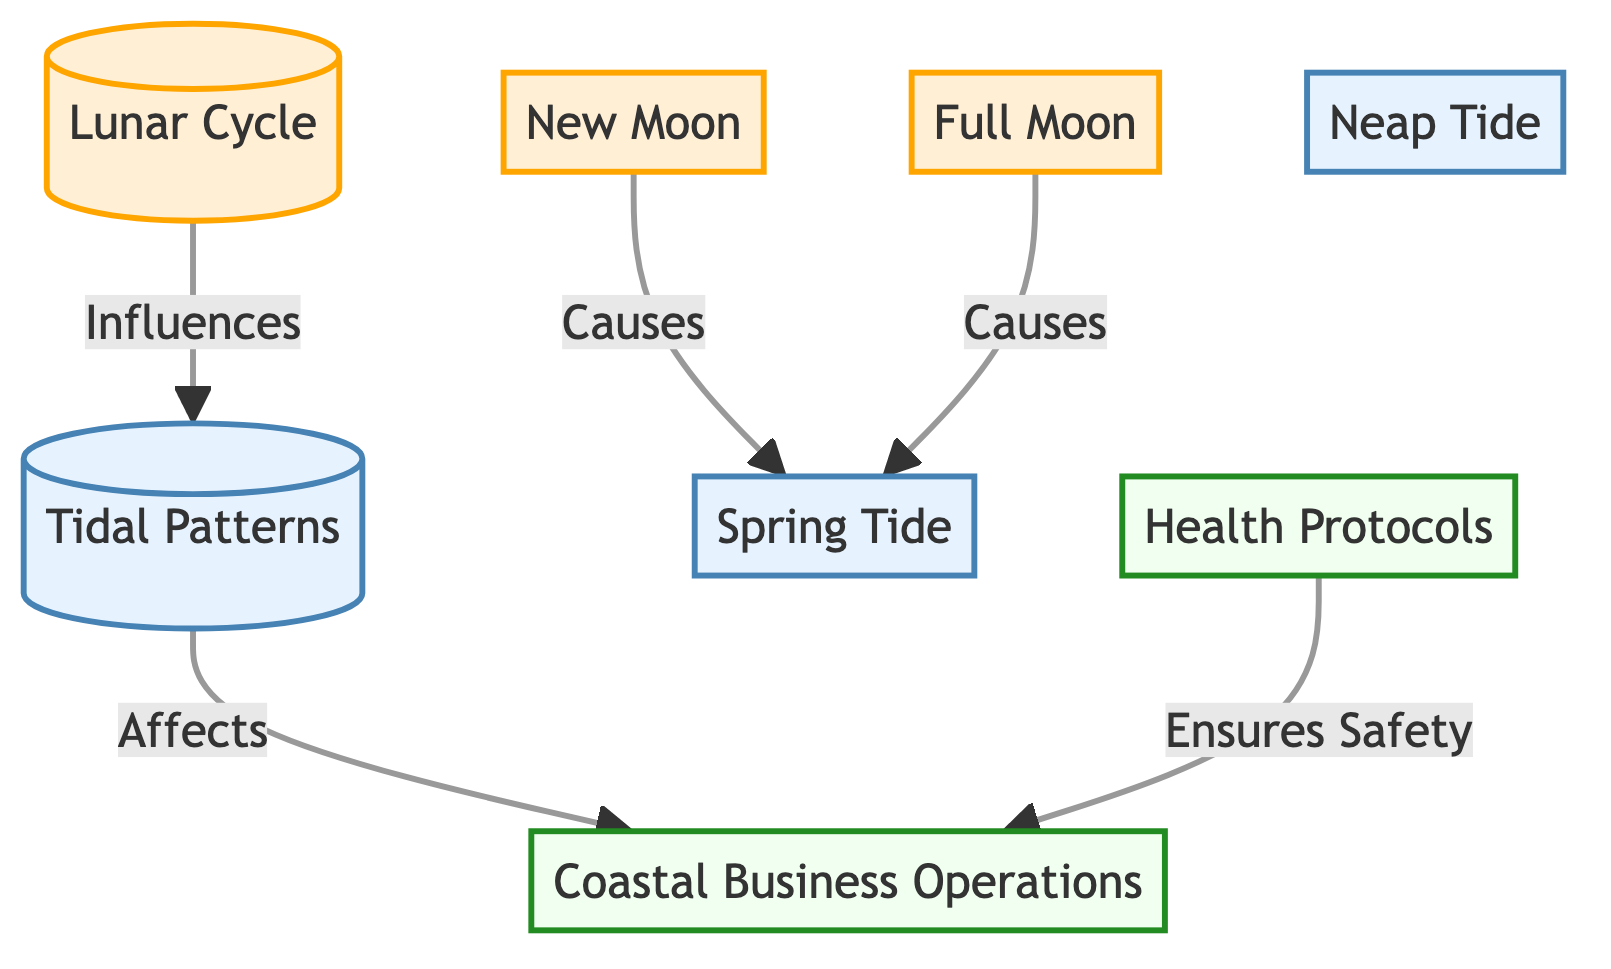What is the main cycle depicted in the diagram? The diagram prominently features the "Lunar Cycle" as the main cycle at the top, which influences the subsequent elements below it.
Answer: Lunar Cycle How many moon phases are illustrated in the diagram? The diagram shows two specific moon phases: "New Moon" and "Full Moon." Thus, there are two phases illustrated.
Answer: 2 What type of tide is caused by a new moon? According to the diagram, a "New Moon" causes a "Spring Tide," indicated by the directed line from the new moon to the spring tide.
Answer: Spring Tide Which phase in the moon cycle significantly contributes to coastal business operations? "Tidal Patterns" is indicated in the diagram to directly affect "Coastal Business Operations," meaning it is the analysis of tides influenced by the moon phases that is significant for coastal businesses.
Answer: Tidal Patterns What health aspect is directly connected to coastal business operations? The diagram states that "Health Protocols" are crucial for ensuring the safety of "Coastal Business Operations," indicating that these protocols are directly linked.
Answer: Health Protocols What is influenced by the lunar cycle? The "Tidal Patterns" are influenced by the "Lunar Cycle," as shown by the arrow indicating this causal relationship in the diagram.
Answer: Tidal Patterns Which tides are associated with both the new and full moon? Both the "New Moon" and "Full Moon" are shown to cause "Spring Tides," which are specifically noted as being linked to these phases in the diagram.
Answer: Spring Tides What provides safety assurance for coastal business operations? The diagram clearly states that "Health Protocols" ensure safety, indicating their role in providing a safe operational environment for these businesses.
Answer: Health Protocols What type of tide is indicated to occur between spring tides? The diagram mentions "Neap Tide" as a type of tide, which implies a contrasting tide in relation to "Spring Tide."
Answer: Neap Tide 